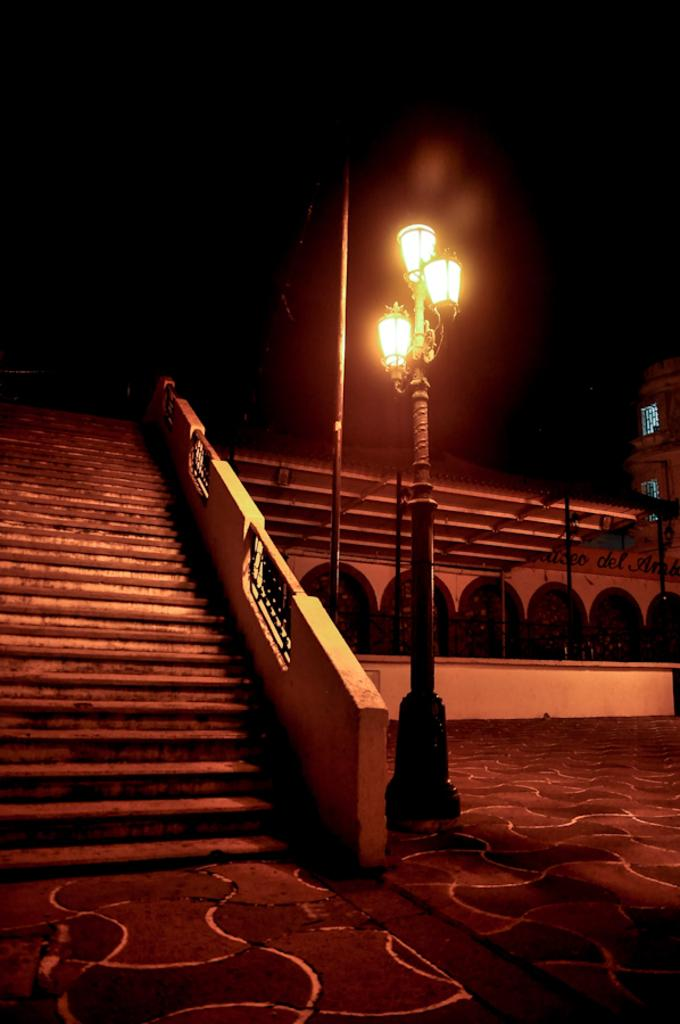What is located in the foreground of the image? There is a street light in the foreground of the image. What architectural feature can be seen on the left side of the image? There are stairs on the left side of the image. What structures are present on the right side of the image? There is a building and a shed on the right side of the image. What is visible in the background of the image? There is a pole visible in the background of the image. What color is the shirt hanging from the pole in the image? There is no shirt hanging from the pole in the image; only the pole is visible. How long does it take for the icicle to form on the street light in the image? There is no icicle present on the street light in the image. 